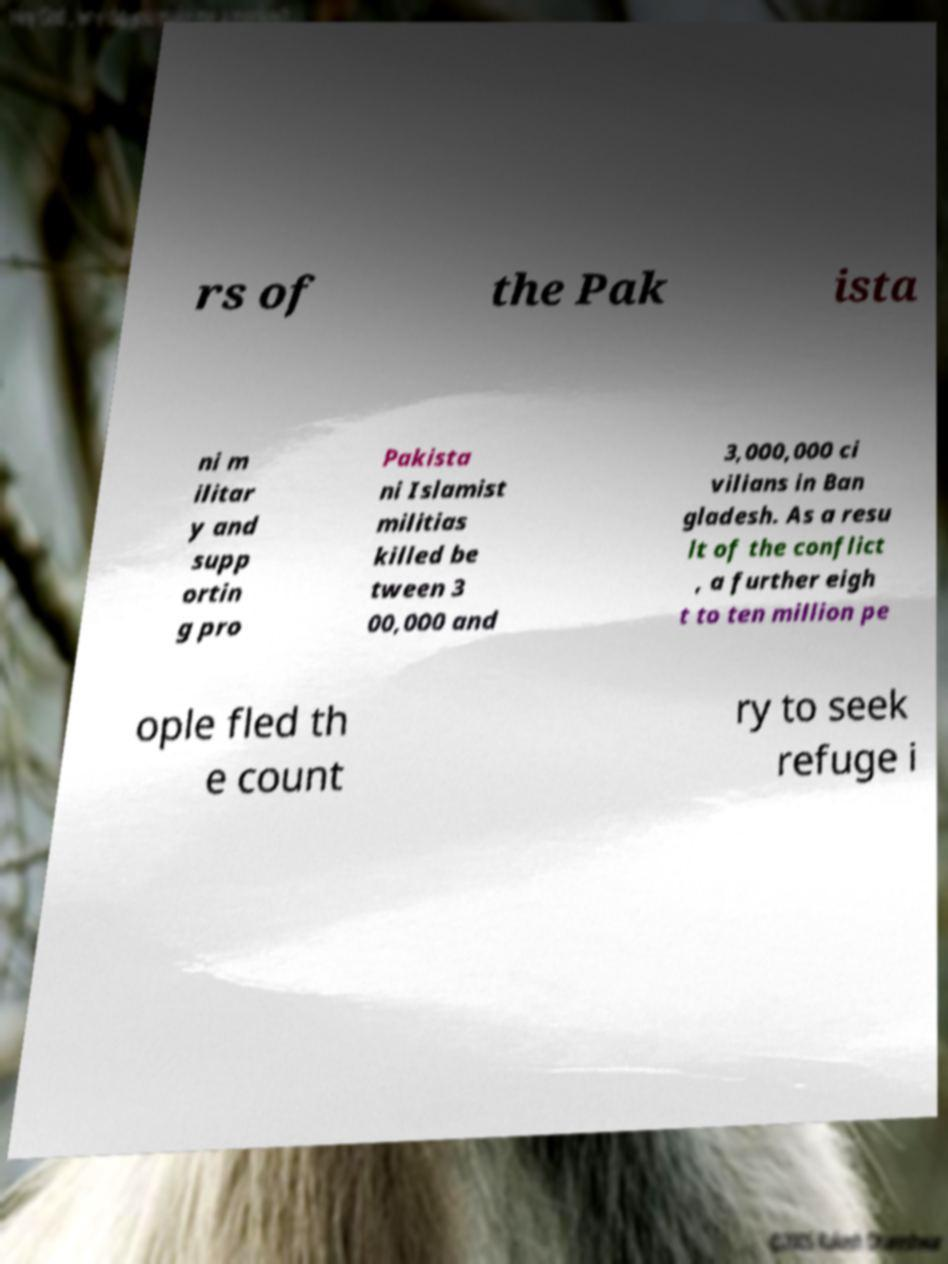Can you read and provide the text displayed in the image?This photo seems to have some interesting text. Can you extract and type it out for me? rs of the Pak ista ni m ilitar y and supp ortin g pro Pakista ni Islamist militias killed be tween 3 00,000 and 3,000,000 ci vilians in Ban gladesh. As a resu lt of the conflict , a further eigh t to ten million pe ople fled th e count ry to seek refuge i 